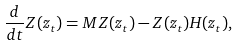<formula> <loc_0><loc_0><loc_500><loc_500>\frac { d } { d t } Z ( z _ { t } ) = M Z ( z _ { t } ) - Z ( z _ { t } ) H ( z _ { t } ) ,</formula> 